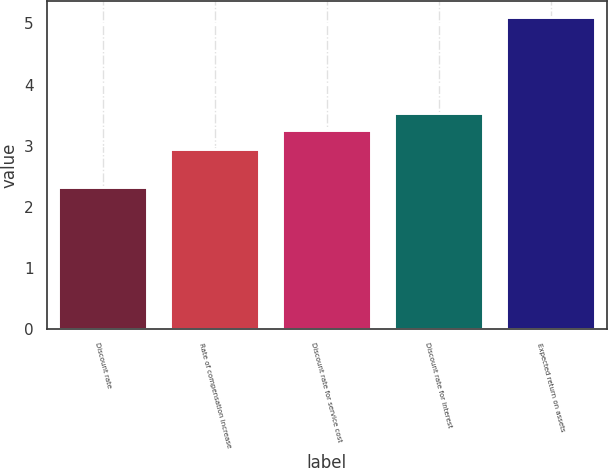<chart> <loc_0><loc_0><loc_500><loc_500><bar_chart><fcel>Discount rate<fcel>Rate of compensation increase<fcel>Discount rate for service cost<fcel>Discount rate for interest<fcel>Expected return on assets<nl><fcel>2.33<fcel>2.94<fcel>3.26<fcel>3.54<fcel>5.11<nl></chart> 